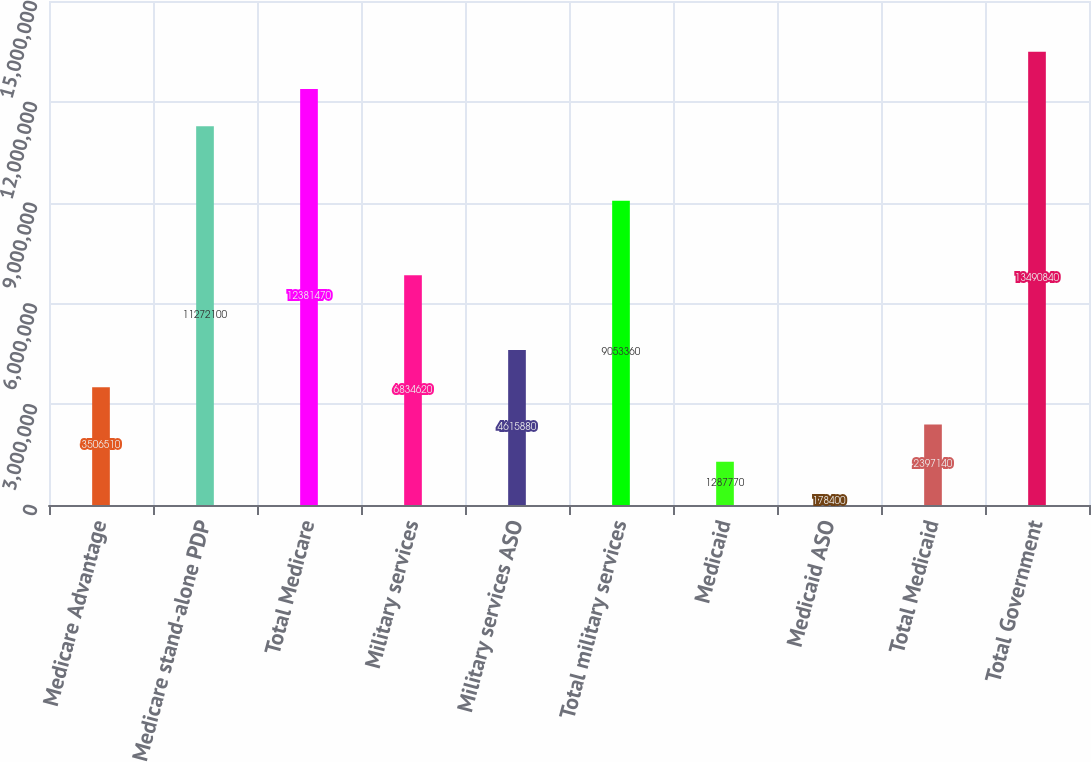Convert chart to OTSL. <chart><loc_0><loc_0><loc_500><loc_500><bar_chart><fcel>Medicare Advantage<fcel>Medicare stand-alone PDP<fcel>Total Medicare<fcel>Military services<fcel>Military services ASO<fcel>Total military services<fcel>Medicaid<fcel>Medicaid ASO<fcel>Total Medicaid<fcel>Total Government<nl><fcel>3.50651e+06<fcel>1.12721e+07<fcel>1.23815e+07<fcel>6.83462e+06<fcel>4.61588e+06<fcel>9.05336e+06<fcel>1.28777e+06<fcel>178400<fcel>2.39714e+06<fcel>1.34908e+07<nl></chart> 